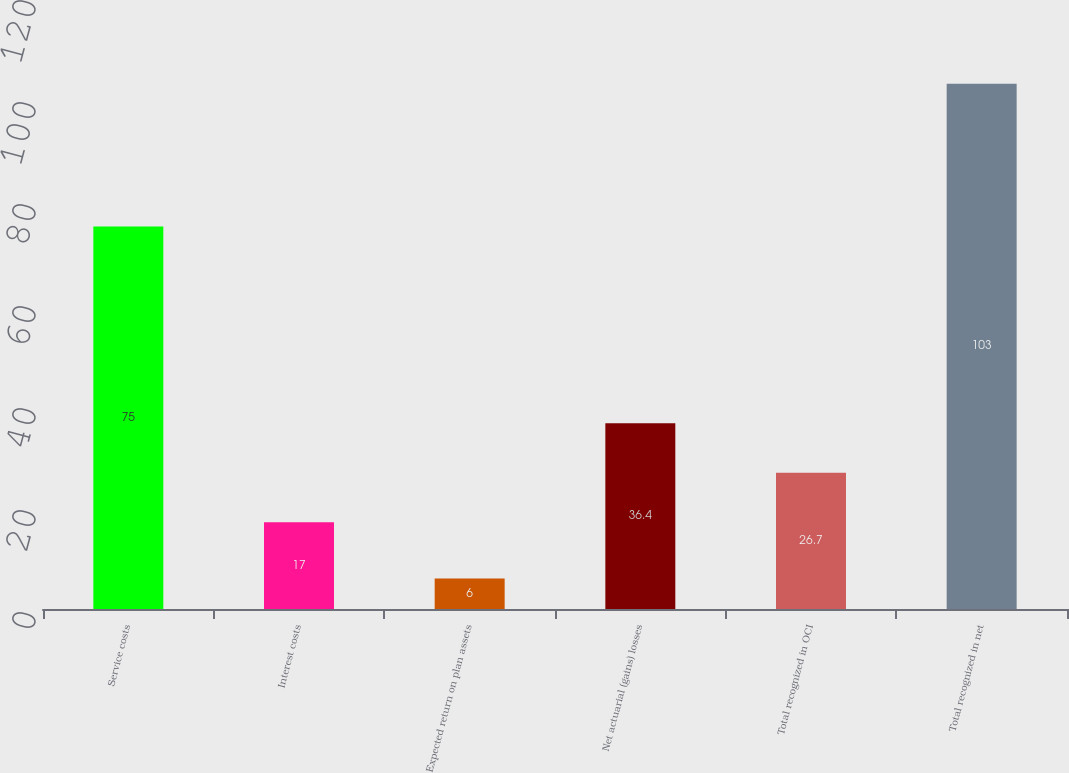Convert chart to OTSL. <chart><loc_0><loc_0><loc_500><loc_500><bar_chart><fcel>Service costs<fcel>Interest costs<fcel>Expected return on plan assets<fcel>Net actuarial (gains) losses<fcel>Total recognized in OCI<fcel>Total recognized in net<nl><fcel>75<fcel>17<fcel>6<fcel>36.4<fcel>26.7<fcel>103<nl></chart> 